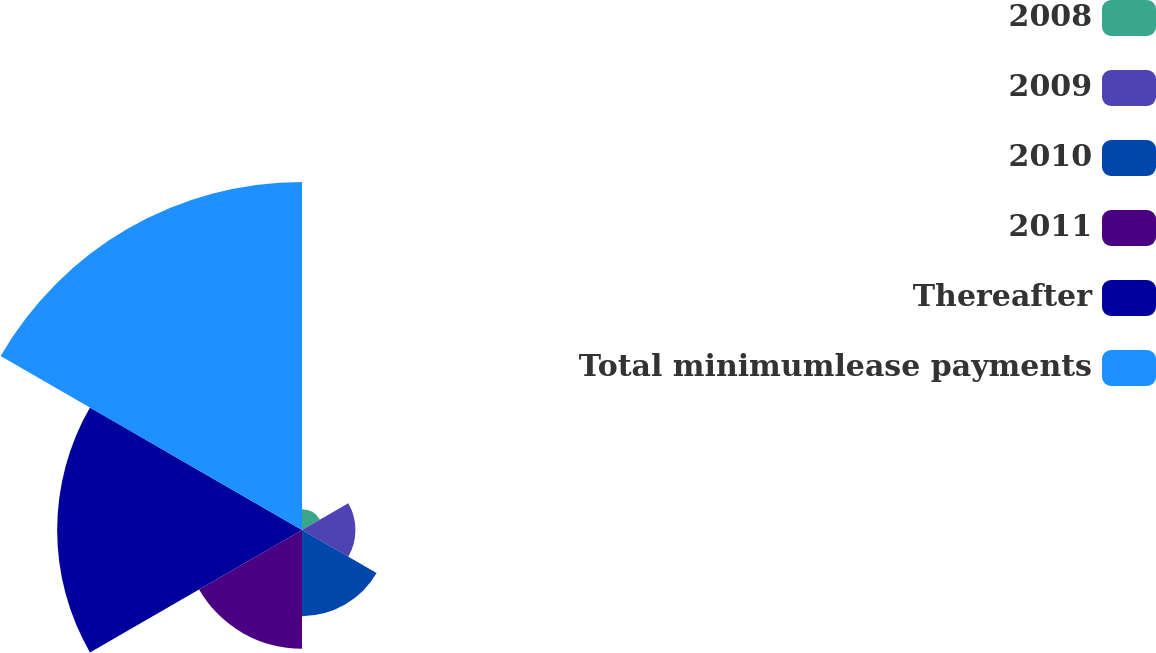Convert chart. <chart><loc_0><loc_0><loc_500><loc_500><pie_chart><fcel>2008<fcel>2009<fcel>2010<fcel>2011<fcel>Thereafter<fcel>Total minimumlease payments<nl><fcel>2.37%<fcel>6.13%<fcel>9.88%<fcel>13.63%<fcel>28.08%<fcel>39.91%<nl></chart> 